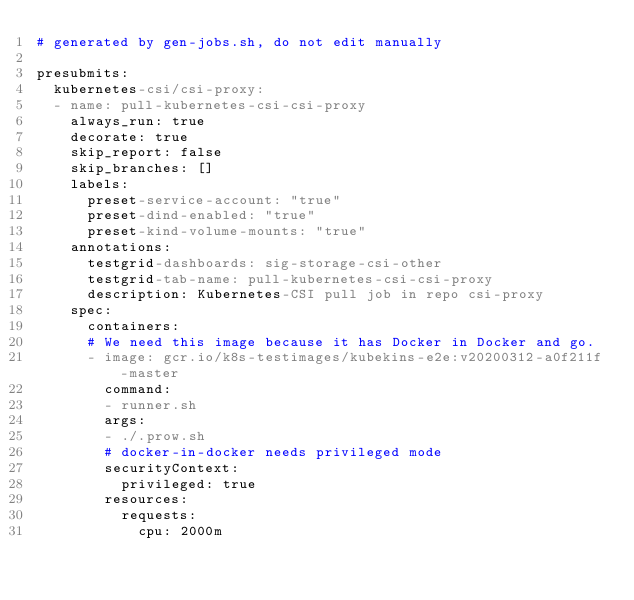Convert code to text. <code><loc_0><loc_0><loc_500><loc_500><_YAML_># generated by gen-jobs.sh, do not edit manually

presubmits:
  kubernetes-csi/csi-proxy:
  - name: pull-kubernetes-csi-csi-proxy
    always_run: true
    decorate: true
    skip_report: false
    skip_branches: []
    labels:
      preset-service-account: "true"
      preset-dind-enabled: "true"
      preset-kind-volume-mounts: "true"
    annotations:
      testgrid-dashboards: sig-storage-csi-other
      testgrid-tab-name: pull-kubernetes-csi-csi-proxy
      description: Kubernetes-CSI pull job in repo csi-proxy
    spec:
      containers:
      # We need this image because it has Docker in Docker and go.
      - image: gcr.io/k8s-testimages/kubekins-e2e:v20200312-a0f211f-master
        command:
        - runner.sh
        args:
        - ./.prow.sh
        # docker-in-docker needs privileged mode
        securityContext:
          privileged: true
        resources:
          requests:
            cpu: 2000m
</code> 